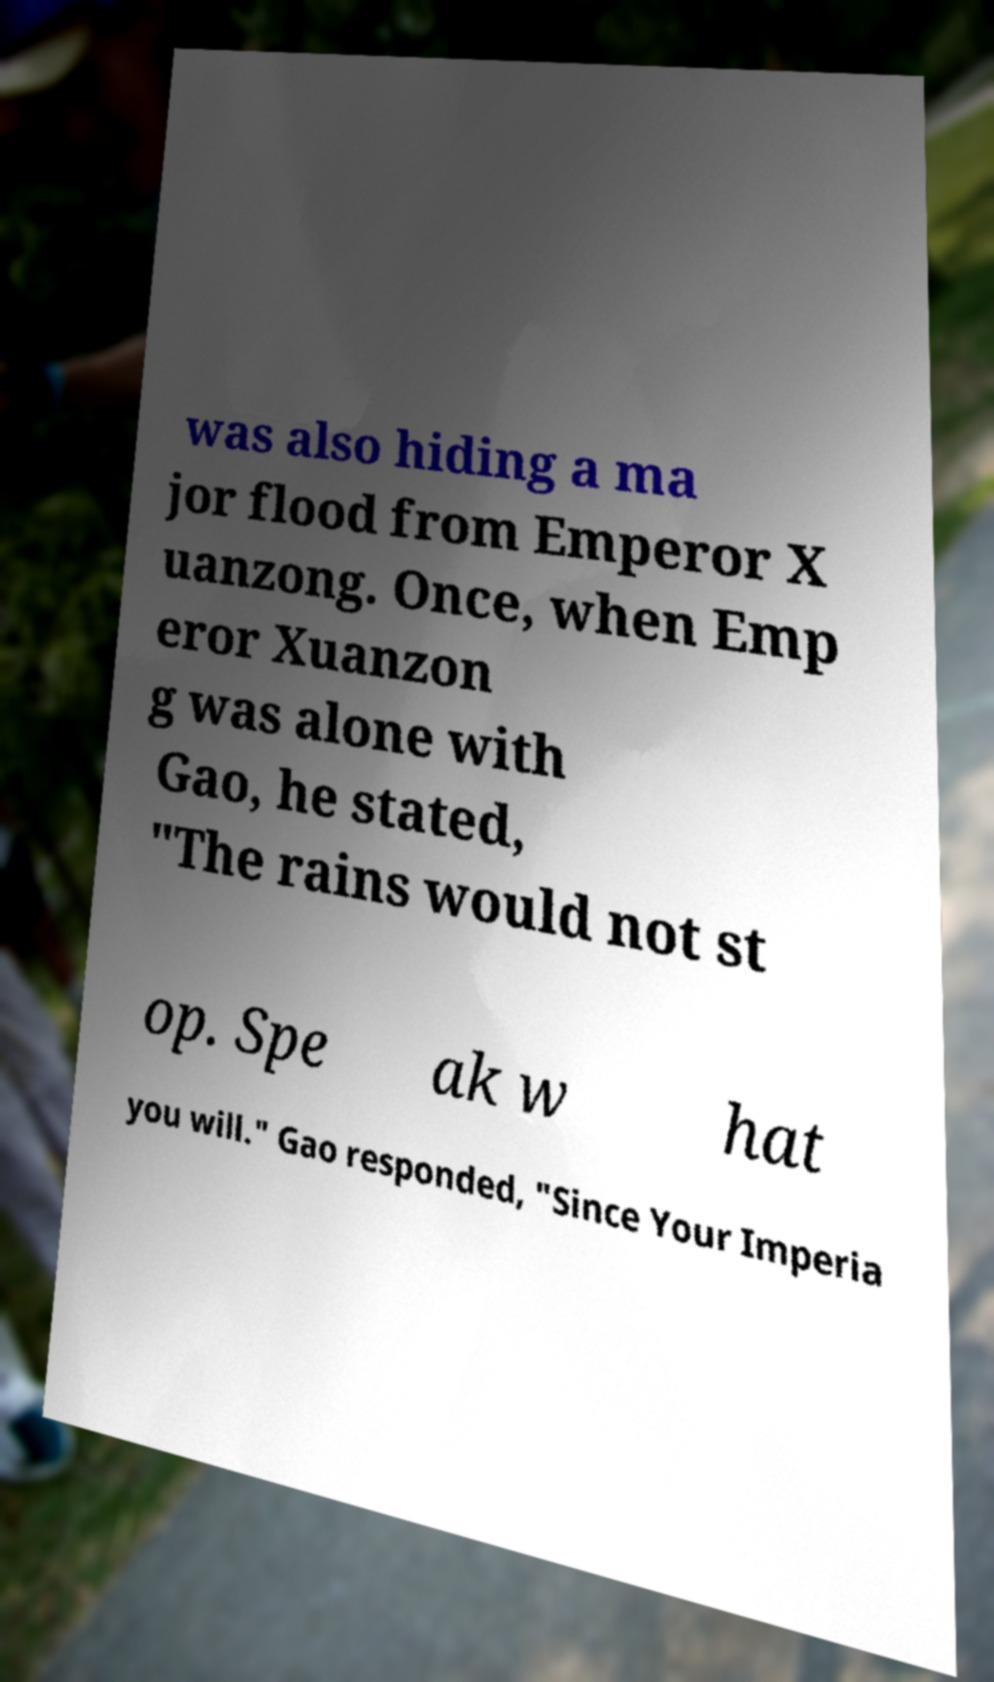Please identify and transcribe the text found in this image. was also hiding a ma jor flood from Emperor X uanzong. Once, when Emp eror Xuanzon g was alone with Gao, he stated, "The rains would not st op. Spe ak w hat you will." Gao responded, "Since Your Imperia 